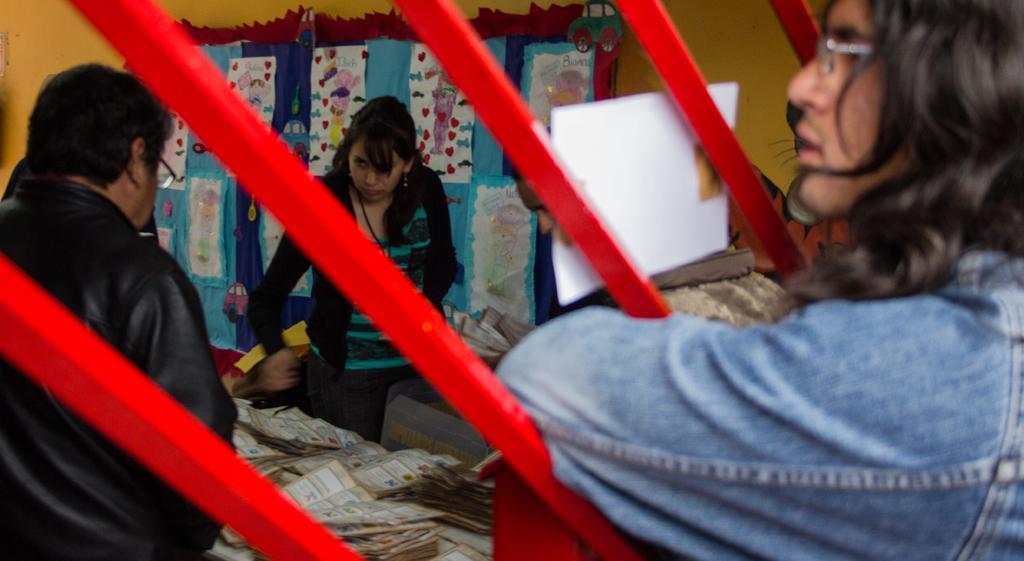In one or two sentences, can you explain what this image depicts? On the right side of this image there is a person. In front of this person there is a iron frame which is painted with red color. On the left side a man and a woman are standing. At the bottom there are few papers placed on a table. In the background there are some posters attached to the wall. Behind this iron frame I can see a white color paper. 